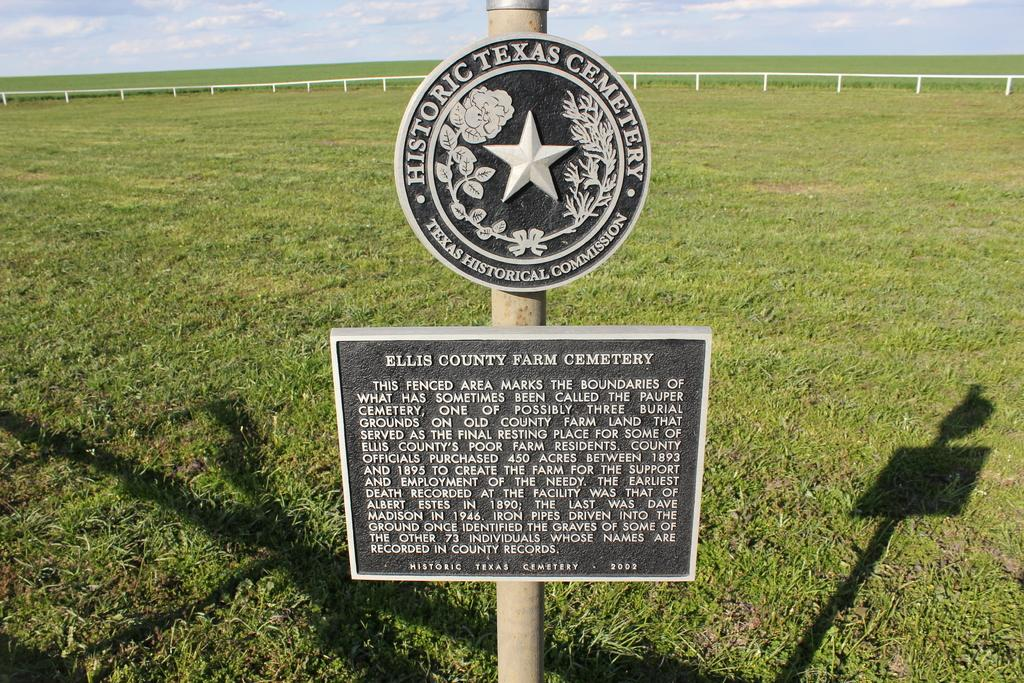What is in the middle of the image? There are two boards fixed to a pole in the middle of the image. What can be seen on the ground in the background? There is grass visible on the ground in the background. What is visible in the sky? There are clouds in the sky. What type of rod is being used to catch fish in the image? There is no rod or fishing activity present in the image. How many stones are visible in the image? There are no stones visible in the image. 